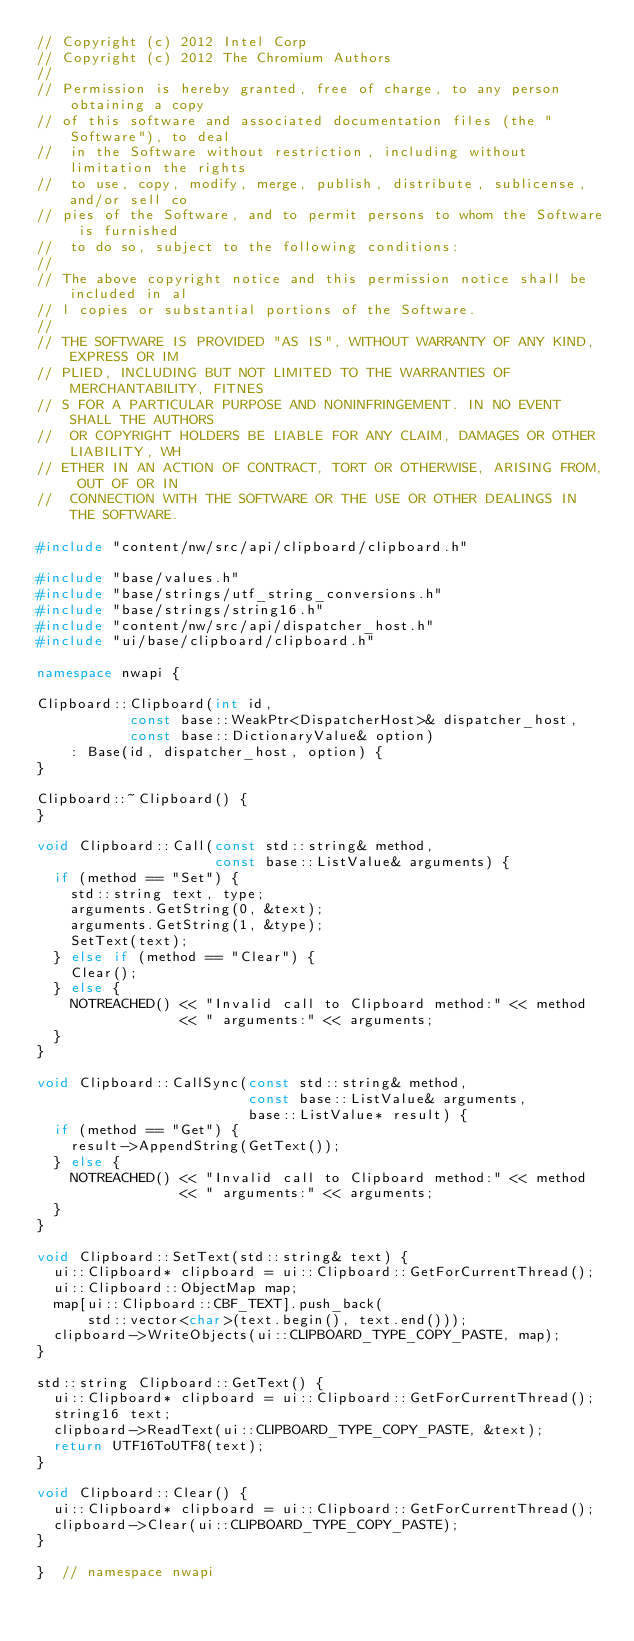Convert code to text. <code><loc_0><loc_0><loc_500><loc_500><_C++_>// Copyright (c) 2012 Intel Corp
// Copyright (c) 2012 The Chromium Authors
// 
// Permission is hereby granted, free of charge, to any person obtaining a copy 
// of this software and associated documentation files (the "Software"), to deal
//  in the Software without restriction, including without limitation the rights
//  to use, copy, modify, merge, publish, distribute, sublicense, and/or sell co
// pies of the Software, and to permit persons to whom the Software is furnished
//  to do so, subject to the following conditions:
// 
// The above copyright notice and this permission notice shall be included in al
// l copies or substantial portions of the Software.
// 
// THE SOFTWARE IS PROVIDED "AS IS", WITHOUT WARRANTY OF ANY KIND, EXPRESS OR IM
// PLIED, INCLUDING BUT NOT LIMITED TO THE WARRANTIES OF MERCHANTABILITY, FITNES
// S FOR A PARTICULAR PURPOSE AND NONINFRINGEMENT. IN NO EVENT SHALL THE AUTHORS
//  OR COPYRIGHT HOLDERS BE LIABLE FOR ANY CLAIM, DAMAGES OR OTHER LIABILITY, WH
// ETHER IN AN ACTION OF CONTRACT, TORT OR OTHERWISE, ARISING FROM, OUT OF OR IN
//  CONNECTION WITH THE SOFTWARE OR THE USE OR OTHER DEALINGS IN THE SOFTWARE.

#include "content/nw/src/api/clipboard/clipboard.h"

#include "base/values.h"
#include "base/strings/utf_string_conversions.h"
#include "base/strings/string16.h"
#include "content/nw/src/api/dispatcher_host.h"
#include "ui/base/clipboard/clipboard.h"

namespace nwapi {

Clipboard::Clipboard(int id,
           const base::WeakPtr<DispatcherHost>& dispatcher_host,
           const base::DictionaryValue& option)
    : Base(id, dispatcher_host, option) {
}

Clipboard::~Clipboard() {
}

void Clipboard::Call(const std::string& method,
                     const base::ListValue& arguments) {
  if (method == "Set") {
    std::string text, type;
    arguments.GetString(0, &text);
    arguments.GetString(1, &type);
    SetText(text);
  } else if (method == "Clear") {
    Clear();
  } else {
    NOTREACHED() << "Invalid call to Clipboard method:" << method
                 << " arguments:" << arguments;
  }
}

void Clipboard::CallSync(const std::string& method,
                         const base::ListValue& arguments,
                         base::ListValue* result) {
  if (method == "Get") {
    result->AppendString(GetText());
  } else {
    NOTREACHED() << "Invalid call to Clipboard method:" << method
                 << " arguments:" << arguments;
  }
}

void Clipboard::SetText(std::string& text) {
  ui::Clipboard* clipboard = ui::Clipboard::GetForCurrentThread();
  ui::Clipboard::ObjectMap map;
  map[ui::Clipboard::CBF_TEXT].push_back(
      std::vector<char>(text.begin(), text.end()));
  clipboard->WriteObjects(ui::CLIPBOARD_TYPE_COPY_PASTE, map);
}

std::string Clipboard::GetText() {
  ui::Clipboard* clipboard = ui::Clipboard::GetForCurrentThread();
  string16 text;
  clipboard->ReadText(ui::CLIPBOARD_TYPE_COPY_PASTE, &text);
  return UTF16ToUTF8(text);
}

void Clipboard::Clear() {
  ui::Clipboard* clipboard = ui::Clipboard::GetForCurrentThread();
  clipboard->Clear(ui::CLIPBOARD_TYPE_COPY_PASTE);
}

}  // namespace nwapi
</code> 